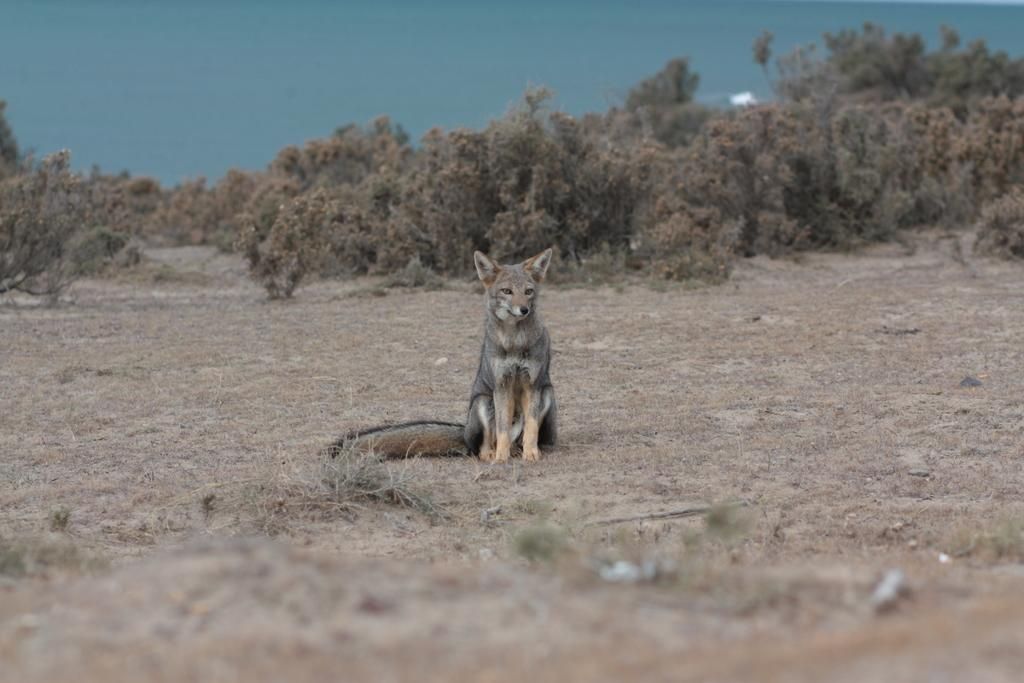What type of creature is in the image? There is an animal in the image. What is the animal doing in the image? The animal is sitting on the ground. What can be seen in the background of the image? There are plants, trees, and the sky visible in the background of the image. What type of fiction is the animal reading in the image? There is no indication that the animal is reading any fiction in the image. 